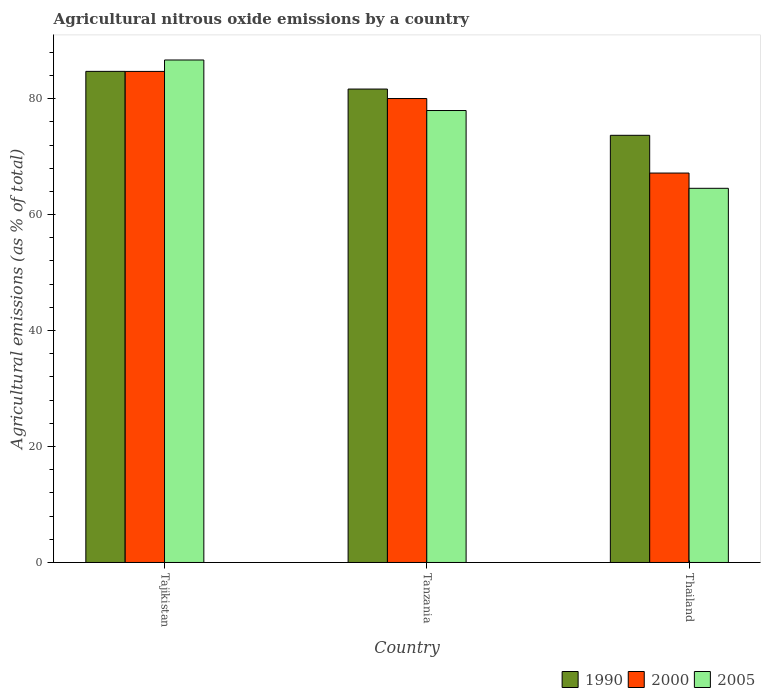How many groups of bars are there?
Give a very brief answer. 3. Are the number of bars on each tick of the X-axis equal?
Give a very brief answer. Yes. How many bars are there on the 1st tick from the left?
Offer a very short reply. 3. How many bars are there on the 2nd tick from the right?
Make the answer very short. 3. What is the label of the 1st group of bars from the left?
Provide a short and direct response. Tajikistan. In how many cases, is the number of bars for a given country not equal to the number of legend labels?
Your answer should be compact. 0. What is the amount of agricultural nitrous oxide emitted in 2000 in Thailand?
Provide a short and direct response. 67.16. Across all countries, what is the maximum amount of agricultural nitrous oxide emitted in 2000?
Your response must be concise. 84.69. Across all countries, what is the minimum amount of agricultural nitrous oxide emitted in 2000?
Your answer should be very brief. 67.16. In which country was the amount of agricultural nitrous oxide emitted in 2005 maximum?
Your answer should be very brief. Tajikistan. In which country was the amount of agricultural nitrous oxide emitted in 2000 minimum?
Provide a succinct answer. Thailand. What is the total amount of agricultural nitrous oxide emitted in 2005 in the graph?
Keep it short and to the point. 229.14. What is the difference between the amount of agricultural nitrous oxide emitted in 2005 in Tanzania and that in Thailand?
Offer a terse response. 13.42. What is the difference between the amount of agricultural nitrous oxide emitted in 1990 in Tajikistan and the amount of agricultural nitrous oxide emitted in 2000 in Tanzania?
Give a very brief answer. 4.69. What is the average amount of agricultural nitrous oxide emitted in 1990 per country?
Your answer should be compact. 80.01. What is the difference between the amount of agricultural nitrous oxide emitted of/in 2005 and amount of agricultural nitrous oxide emitted of/in 2000 in Tanzania?
Offer a very short reply. -2.07. What is the ratio of the amount of agricultural nitrous oxide emitted in 1990 in Tajikistan to that in Tanzania?
Keep it short and to the point. 1.04. Is the amount of agricultural nitrous oxide emitted in 2005 in Tajikistan less than that in Thailand?
Your response must be concise. No. What is the difference between the highest and the second highest amount of agricultural nitrous oxide emitted in 2005?
Make the answer very short. -13.42. What is the difference between the highest and the lowest amount of agricultural nitrous oxide emitted in 1990?
Give a very brief answer. 11.03. Is the sum of the amount of agricultural nitrous oxide emitted in 2005 in Tanzania and Thailand greater than the maximum amount of agricultural nitrous oxide emitted in 1990 across all countries?
Offer a terse response. Yes. What does the 3rd bar from the left in Tanzania represents?
Offer a very short reply. 2005. What does the 3rd bar from the right in Tanzania represents?
Make the answer very short. 1990. Is it the case that in every country, the sum of the amount of agricultural nitrous oxide emitted in 1990 and amount of agricultural nitrous oxide emitted in 2005 is greater than the amount of agricultural nitrous oxide emitted in 2000?
Your answer should be very brief. Yes. How many bars are there?
Provide a short and direct response. 9. Are all the bars in the graph horizontal?
Offer a very short reply. No. Does the graph contain grids?
Your answer should be very brief. No. Where does the legend appear in the graph?
Offer a very short reply. Bottom right. How many legend labels are there?
Your response must be concise. 3. How are the legend labels stacked?
Give a very brief answer. Horizontal. What is the title of the graph?
Keep it short and to the point. Agricultural nitrous oxide emissions by a country. What is the label or title of the X-axis?
Make the answer very short. Country. What is the label or title of the Y-axis?
Offer a terse response. Agricultural emissions (as % of total). What is the Agricultural emissions (as % of total) in 1990 in Tajikistan?
Keep it short and to the point. 84.7. What is the Agricultural emissions (as % of total) of 2000 in Tajikistan?
Provide a short and direct response. 84.69. What is the Agricultural emissions (as % of total) of 2005 in Tajikistan?
Give a very brief answer. 86.66. What is the Agricultural emissions (as % of total) in 1990 in Tanzania?
Offer a terse response. 81.65. What is the Agricultural emissions (as % of total) in 2000 in Tanzania?
Provide a succinct answer. 80.01. What is the Agricultural emissions (as % of total) of 2005 in Tanzania?
Provide a short and direct response. 77.95. What is the Agricultural emissions (as % of total) of 1990 in Thailand?
Your response must be concise. 73.67. What is the Agricultural emissions (as % of total) in 2000 in Thailand?
Your answer should be very brief. 67.16. What is the Agricultural emissions (as % of total) of 2005 in Thailand?
Keep it short and to the point. 64.53. Across all countries, what is the maximum Agricultural emissions (as % of total) in 1990?
Provide a succinct answer. 84.7. Across all countries, what is the maximum Agricultural emissions (as % of total) of 2000?
Provide a succinct answer. 84.69. Across all countries, what is the maximum Agricultural emissions (as % of total) of 2005?
Make the answer very short. 86.66. Across all countries, what is the minimum Agricultural emissions (as % of total) in 1990?
Your answer should be very brief. 73.67. Across all countries, what is the minimum Agricultural emissions (as % of total) in 2000?
Your answer should be very brief. 67.16. Across all countries, what is the minimum Agricultural emissions (as % of total) of 2005?
Keep it short and to the point. 64.53. What is the total Agricultural emissions (as % of total) of 1990 in the graph?
Your answer should be compact. 240.02. What is the total Agricultural emissions (as % of total) of 2000 in the graph?
Provide a succinct answer. 231.87. What is the total Agricultural emissions (as % of total) in 2005 in the graph?
Your response must be concise. 229.14. What is the difference between the Agricultural emissions (as % of total) of 1990 in Tajikistan and that in Tanzania?
Make the answer very short. 3.05. What is the difference between the Agricultural emissions (as % of total) of 2000 in Tajikistan and that in Tanzania?
Offer a terse response. 4.68. What is the difference between the Agricultural emissions (as % of total) of 2005 in Tajikistan and that in Tanzania?
Give a very brief answer. 8.71. What is the difference between the Agricultural emissions (as % of total) in 1990 in Tajikistan and that in Thailand?
Your answer should be very brief. 11.03. What is the difference between the Agricultural emissions (as % of total) in 2000 in Tajikistan and that in Thailand?
Make the answer very short. 17.53. What is the difference between the Agricultural emissions (as % of total) in 2005 in Tajikistan and that in Thailand?
Keep it short and to the point. 22.13. What is the difference between the Agricultural emissions (as % of total) in 1990 in Tanzania and that in Thailand?
Provide a succinct answer. 7.98. What is the difference between the Agricultural emissions (as % of total) of 2000 in Tanzania and that in Thailand?
Make the answer very short. 12.85. What is the difference between the Agricultural emissions (as % of total) in 2005 in Tanzania and that in Thailand?
Your response must be concise. 13.42. What is the difference between the Agricultural emissions (as % of total) in 1990 in Tajikistan and the Agricultural emissions (as % of total) in 2000 in Tanzania?
Offer a very short reply. 4.69. What is the difference between the Agricultural emissions (as % of total) of 1990 in Tajikistan and the Agricultural emissions (as % of total) of 2005 in Tanzania?
Keep it short and to the point. 6.75. What is the difference between the Agricultural emissions (as % of total) in 2000 in Tajikistan and the Agricultural emissions (as % of total) in 2005 in Tanzania?
Your answer should be compact. 6.74. What is the difference between the Agricultural emissions (as % of total) of 1990 in Tajikistan and the Agricultural emissions (as % of total) of 2000 in Thailand?
Ensure brevity in your answer.  17.54. What is the difference between the Agricultural emissions (as % of total) of 1990 in Tajikistan and the Agricultural emissions (as % of total) of 2005 in Thailand?
Provide a short and direct response. 20.17. What is the difference between the Agricultural emissions (as % of total) of 2000 in Tajikistan and the Agricultural emissions (as % of total) of 2005 in Thailand?
Provide a short and direct response. 20.16. What is the difference between the Agricultural emissions (as % of total) of 1990 in Tanzania and the Agricultural emissions (as % of total) of 2000 in Thailand?
Offer a very short reply. 14.49. What is the difference between the Agricultural emissions (as % of total) in 1990 in Tanzania and the Agricultural emissions (as % of total) in 2005 in Thailand?
Provide a succinct answer. 17.12. What is the difference between the Agricultural emissions (as % of total) of 2000 in Tanzania and the Agricultural emissions (as % of total) of 2005 in Thailand?
Your response must be concise. 15.48. What is the average Agricultural emissions (as % of total) in 1990 per country?
Offer a very short reply. 80.01. What is the average Agricultural emissions (as % of total) in 2000 per country?
Ensure brevity in your answer.  77.29. What is the average Agricultural emissions (as % of total) in 2005 per country?
Your response must be concise. 76.38. What is the difference between the Agricultural emissions (as % of total) of 1990 and Agricultural emissions (as % of total) of 2000 in Tajikistan?
Make the answer very short. 0.01. What is the difference between the Agricultural emissions (as % of total) in 1990 and Agricultural emissions (as % of total) in 2005 in Tajikistan?
Your answer should be compact. -1.96. What is the difference between the Agricultural emissions (as % of total) in 2000 and Agricultural emissions (as % of total) in 2005 in Tajikistan?
Your answer should be compact. -1.97. What is the difference between the Agricultural emissions (as % of total) in 1990 and Agricultural emissions (as % of total) in 2000 in Tanzania?
Provide a short and direct response. 1.63. What is the difference between the Agricultural emissions (as % of total) of 1990 and Agricultural emissions (as % of total) of 2005 in Tanzania?
Your answer should be compact. 3.7. What is the difference between the Agricultural emissions (as % of total) of 2000 and Agricultural emissions (as % of total) of 2005 in Tanzania?
Offer a very short reply. 2.07. What is the difference between the Agricultural emissions (as % of total) in 1990 and Agricultural emissions (as % of total) in 2000 in Thailand?
Your response must be concise. 6.51. What is the difference between the Agricultural emissions (as % of total) of 1990 and Agricultural emissions (as % of total) of 2005 in Thailand?
Offer a terse response. 9.14. What is the difference between the Agricultural emissions (as % of total) in 2000 and Agricultural emissions (as % of total) in 2005 in Thailand?
Your response must be concise. 2.63. What is the ratio of the Agricultural emissions (as % of total) of 1990 in Tajikistan to that in Tanzania?
Your answer should be compact. 1.04. What is the ratio of the Agricultural emissions (as % of total) in 2000 in Tajikistan to that in Tanzania?
Provide a succinct answer. 1.06. What is the ratio of the Agricultural emissions (as % of total) in 2005 in Tajikistan to that in Tanzania?
Offer a very short reply. 1.11. What is the ratio of the Agricultural emissions (as % of total) of 1990 in Tajikistan to that in Thailand?
Make the answer very short. 1.15. What is the ratio of the Agricultural emissions (as % of total) in 2000 in Tajikistan to that in Thailand?
Make the answer very short. 1.26. What is the ratio of the Agricultural emissions (as % of total) of 2005 in Tajikistan to that in Thailand?
Provide a short and direct response. 1.34. What is the ratio of the Agricultural emissions (as % of total) in 1990 in Tanzania to that in Thailand?
Make the answer very short. 1.11. What is the ratio of the Agricultural emissions (as % of total) of 2000 in Tanzania to that in Thailand?
Your answer should be very brief. 1.19. What is the ratio of the Agricultural emissions (as % of total) in 2005 in Tanzania to that in Thailand?
Keep it short and to the point. 1.21. What is the difference between the highest and the second highest Agricultural emissions (as % of total) of 1990?
Your answer should be compact. 3.05. What is the difference between the highest and the second highest Agricultural emissions (as % of total) in 2000?
Offer a terse response. 4.68. What is the difference between the highest and the second highest Agricultural emissions (as % of total) in 2005?
Offer a very short reply. 8.71. What is the difference between the highest and the lowest Agricultural emissions (as % of total) of 1990?
Your response must be concise. 11.03. What is the difference between the highest and the lowest Agricultural emissions (as % of total) in 2000?
Offer a terse response. 17.53. What is the difference between the highest and the lowest Agricultural emissions (as % of total) in 2005?
Keep it short and to the point. 22.13. 